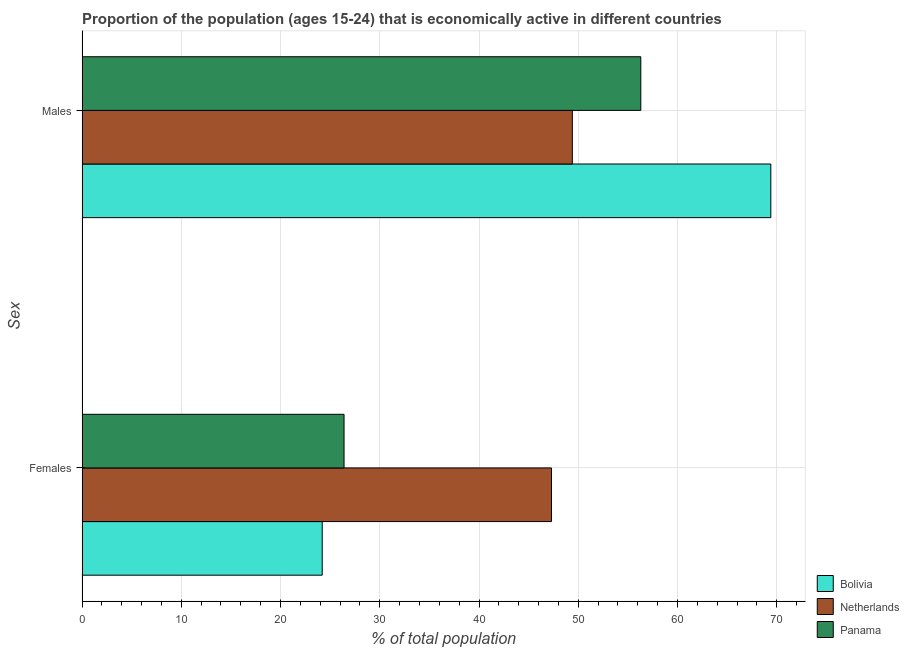How many different coloured bars are there?
Keep it short and to the point. 3. Are the number of bars on each tick of the Y-axis equal?
Keep it short and to the point. Yes. How many bars are there on the 1st tick from the bottom?
Offer a terse response. 3. What is the label of the 1st group of bars from the top?
Your response must be concise. Males. What is the percentage of economically active female population in Netherlands?
Your answer should be very brief. 47.3. Across all countries, what is the maximum percentage of economically active female population?
Your answer should be compact. 47.3. Across all countries, what is the minimum percentage of economically active female population?
Offer a very short reply. 24.2. In which country was the percentage of economically active female population maximum?
Keep it short and to the point. Netherlands. What is the total percentage of economically active male population in the graph?
Make the answer very short. 175.1. What is the difference between the percentage of economically active male population in Netherlands and that in Bolivia?
Your answer should be compact. -20. What is the difference between the percentage of economically active female population in Panama and the percentage of economically active male population in Bolivia?
Offer a terse response. -43. What is the average percentage of economically active female population per country?
Make the answer very short. 32.63. What is the difference between the percentage of economically active male population and percentage of economically active female population in Panama?
Provide a short and direct response. 29.9. In how many countries, is the percentage of economically active female population greater than 70 %?
Keep it short and to the point. 0. What is the ratio of the percentage of economically active female population in Bolivia to that in Netherlands?
Offer a terse response. 0.51. Is the percentage of economically active female population in Netherlands less than that in Panama?
Provide a succinct answer. No. What does the 1st bar from the top in Females represents?
Your answer should be compact. Panama. What does the 3rd bar from the bottom in Males represents?
Your answer should be compact. Panama. How many bars are there?
Make the answer very short. 6. What is the difference between two consecutive major ticks on the X-axis?
Give a very brief answer. 10. Does the graph contain any zero values?
Provide a succinct answer. No. Does the graph contain grids?
Provide a short and direct response. Yes. How many legend labels are there?
Make the answer very short. 3. How are the legend labels stacked?
Give a very brief answer. Vertical. What is the title of the graph?
Provide a short and direct response. Proportion of the population (ages 15-24) that is economically active in different countries. What is the label or title of the X-axis?
Keep it short and to the point. % of total population. What is the label or title of the Y-axis?
Offer a terse response. Sex. What is the % of total population of Bolivia in Females?
Your response must be concise. 24.2. What is the % of total population of Netherlands in Females?
Give a very brief answer. 47.3. What is the % of total population of Panama in Females?
Your response must be concise. 26.4. What is the % of total population in Bolivia in Males?
Ensure brevity in your answer.  69.4. What is the % of total population in Netherlands in Males?
Offer a very short reply. 49.4. What is the % of total population in Panama in Males?
Offer a terse response. 56.3. Across all Sex, what is the maximum % of total population in Bolivia?
Keep it short and to the point. 69.4. Across all Sex, what is the maximum % of total population in Netherlands?
Offer a terse response. 49.4. Across all Sex, what is the maximum % of total population in Panama?
Provide a short and direct response. 56.3. Across all Sex, what is the minimum % of total population in Bolivia?
Give a very brief answer. 24.2. Across all Sex, what is the minimum % of total population of Netherlands?
Provide a succinct answer. 47.3. Across all Sex, what is the minimum % of total population of Panama?
Make the answer very short. 26.4. What is the total % of total population of Bolivia in the graph?
Your answer should be compact. 93.6. What is the total % of total population of Netherlands in the graph?
Offer a very short reply. 96.7. What is the total % of total population of Panama in the graph?
Make the answer very short. 82.7. What is the difference between the % of total population in Bolivia in Females and that in Males?
Your response must be concise. -45.2. What is the difference between the % of total population of Panama in Females and that in Males?
Ensure brevity in your answer.  -29.9. What is the difference between the % of total population of Bolivia in Females and the % of total population of Netherlands in Males?
Give a very brief answer. -25.2. What is the difference between the % of total population of Bolivia in Females and the % of total population of Panama in Males?
Make the answer very short. -32.1. What is the difference between the % of total population of Netherlands in Females and the % of total population of Panama in Males?
Keep it short and to the point. -9. What is the average % of total population of Bolivia per Sex?
Your response must be concise. 46.8. What is the average % of total population in Netherlands per Sex?
Keep it short and to the point. 48.35. What is the average % of total population in Panama per Sex?
Provide a succinct answer. 41.35. What is the difference between the % of total population in Bolivia and % of total population in Netherlands in Females?
Provide a short and direct response. -23.1. What is the difference between the % of total population in Bolivia and % of total population in Panama in Females?
Your response must be concise. -2.2. What is the difference between the % of total population of Netherlands and % of total population of Panama in Females?
Provide a short and direct response. 20.9. What is the ratio of the % of total population in Bolivia in Females to that in Males?
Keep it short and to the point. 0.35. What is the ratio of the % of total population of Netherlands in Females to that in Males?
Keep it short and to the point. 0.96. What is the ratio of the % of total population in Panama in Females to that in Males?
Keep it short and to the point. 0.47. What is the difference between the highest and the second highest % of total population in Bolivia?
Offer a terse response. 45.2. What is the difference between the highest and the second highest % of total population of Netherlands?
Ensure brevity in your answer.  2.1. What is the difference between the highest and the second highest % of total population of Panama?
Give a very brief answer. 29.9. What is the difference between the highest and the lowest % of total population of Bolivia?
Make the answer very short. 45.2. What is the difference between the highest and the lowest % of total population of Netherlands?
Your response must be concise. 2.1. What is the difference between the highest and the lowest % of total population of Panama?
Give a very brief answer. 29.9. 